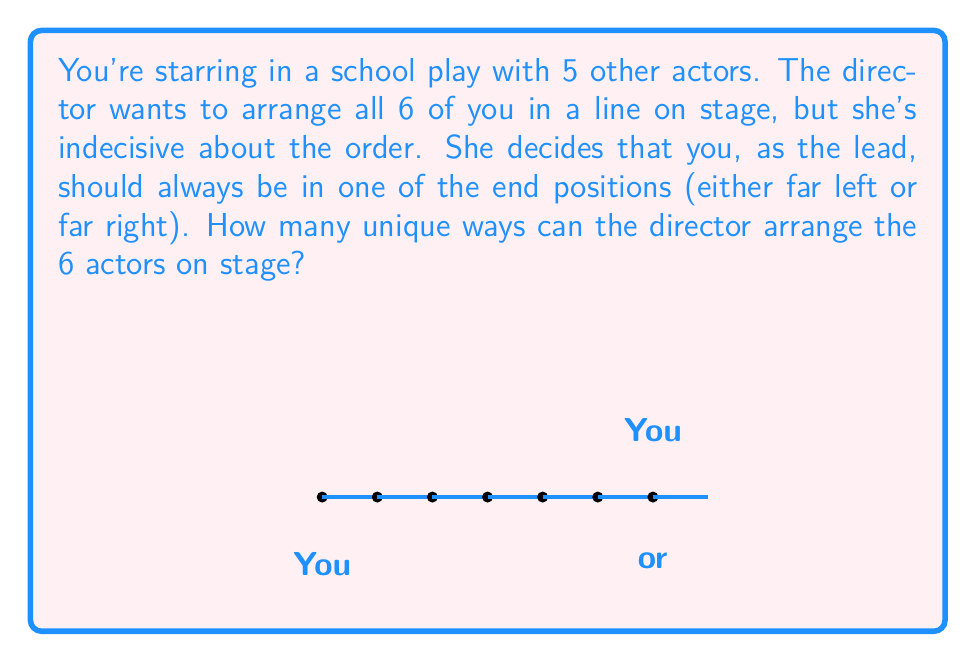Can you answer this question? Let's approach this step-by-step using permutation groups:

1) First, we need to consider that you, as the lead actor, can be in one of two positions: far left or far right. This gives us 2 cases to consider.

2) For each of these cases, we need to arrange the remaining 5 actors.

3) The number of ways to arrange 5 actors is given by the permutation formula:
   $P(5,5) = 5! = 5 \times 4 \times 3 \times 2 \times 1 = 120$

4) Since this arrangement of 5 actors can occur for both of your positions (left and right), we multiply by 2:

   $$\text{Total arrangements} = 2 \times P(5,5) = 2 \times 120 = 240$$

5) In group theory terms, this is equivalent to the order of the symmetry group $S_6$ (all permutations of 6 elements) divided by 3 (as you're restricted to 2 positions out of 6):

   $$\frac{|S_6|}{3} = \frac{6!}{3} = \frac{720}{3} = 240$$

Thus, there are 240 unique ways to arrange the 6 actors on stage with you at one of the ends.
Answer: 240 